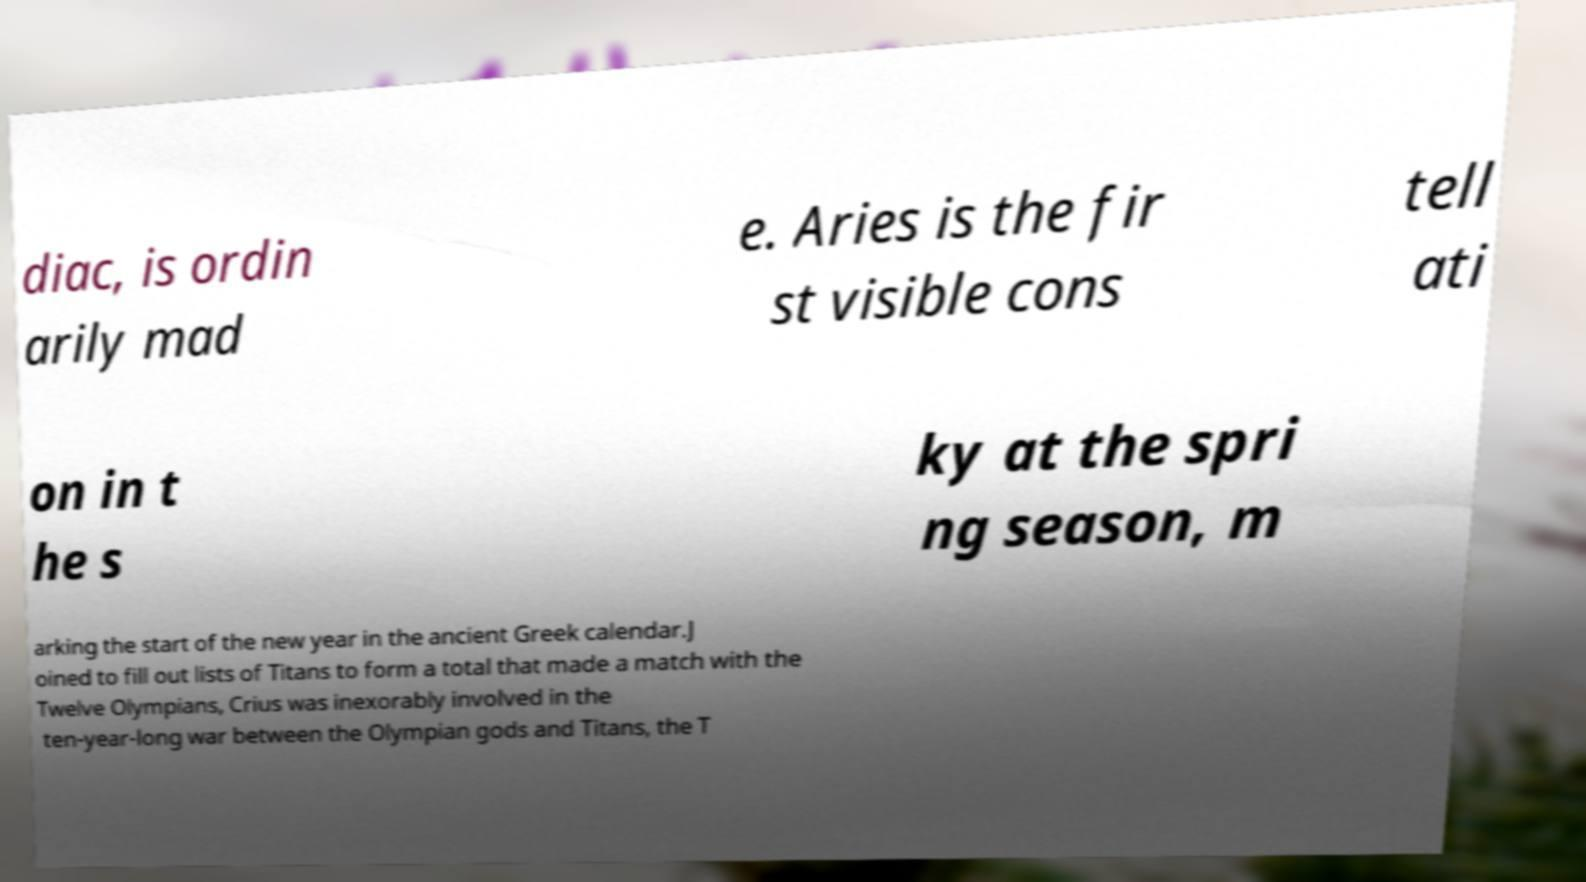Please identify and transcribe the text found in this image. diac, is ordin arily mad e. Aries is the fir st visible cons tell ati on in t he s ky at the spri ng season, m arking the start of the new year in the ancient Greek calendar.J oined to fill out lists of Titans to form a total that made a match with the Twelve Olympians, Crius was inexorably involved in the ten-year-long war between the Olympian gods and Titans, the T 